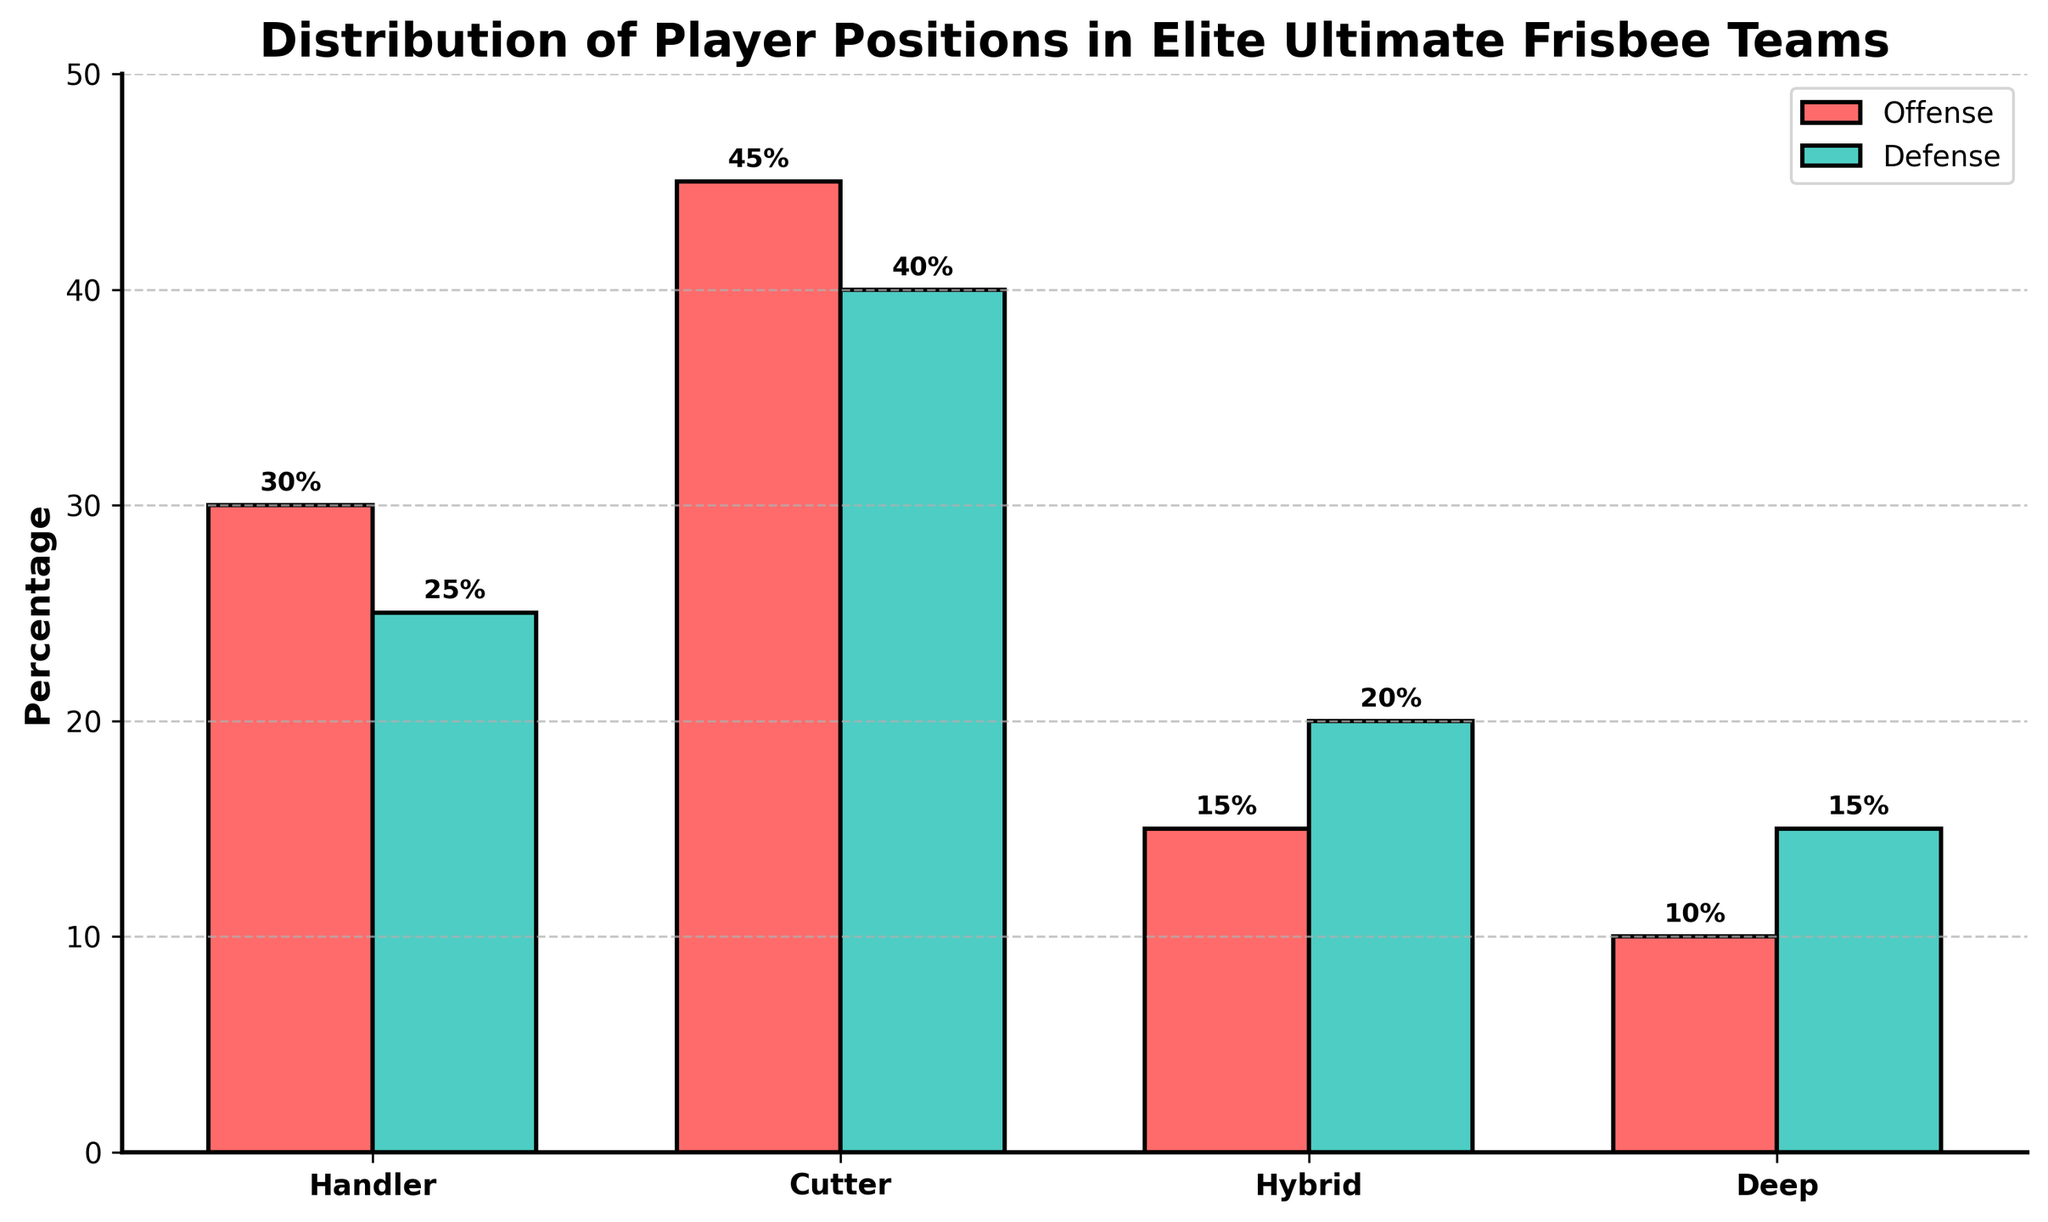What's the total percentage of players in offensive roles? To find the total percentage of players in offensive roles, add the percentages for Handler, Cutter, Hybrid, and Deep in the Offense column: 30 + 45 + 15 + 10 = 100.
Answer: 100% Which position has the highest percentage of players in defensive roles? Look at the Defense column and find the highest value. Cutter has the highest percentage at 40%.
Answer: Cutter Are there more Hybrid players in offensive or defensive roles? Compare the percentages of Hybrid players in the Offense column (15%) with those in the Defense column (20%). There are more Hybrid players in defensive roles.
Answer: Defensive roles What’s the difference in player percentages between Cutter and Handler in offensive roles? Subtract the percentage of Handlers (30%) from the percentage of Cutters (45%): 45 - 30 = 15%.
Answer: 15% How many positions have more players in offensive roles than defensive roles? Compare the offense and defense values for each position: Handler (30 > 25), Cutter (45 > 40), Hybrid (15 < 20), Deep (10 < 15). Two positions (Handler, Cutter) have more offensive players.
Answer: 2 What's the average percentage of players in defensive roles across all positions? Add the percentages for all positions in the Defense column: 25 + 40 + 20 + 15 = 100. Divide by the number of positions (4): 100/4 = 25%.
Answer: 25% Of the positions, which has the smallest overall percentage when combining offense and defense roles? Add the percentage of both offense and defense values for each position: Handler: 30+25=55, Cutter: 45+40=85, Hybrid: 15+20=35, Deep: 10+15=25. Deep has the smallest overall percentage of 25.
Answer: Deep Which color represents defensive roles in the chart, and how can you identify it? The color for defensive roles is green. You can identify this by looking at the legend where 'Defense' corresponds to the green bar.
Answer: Green 